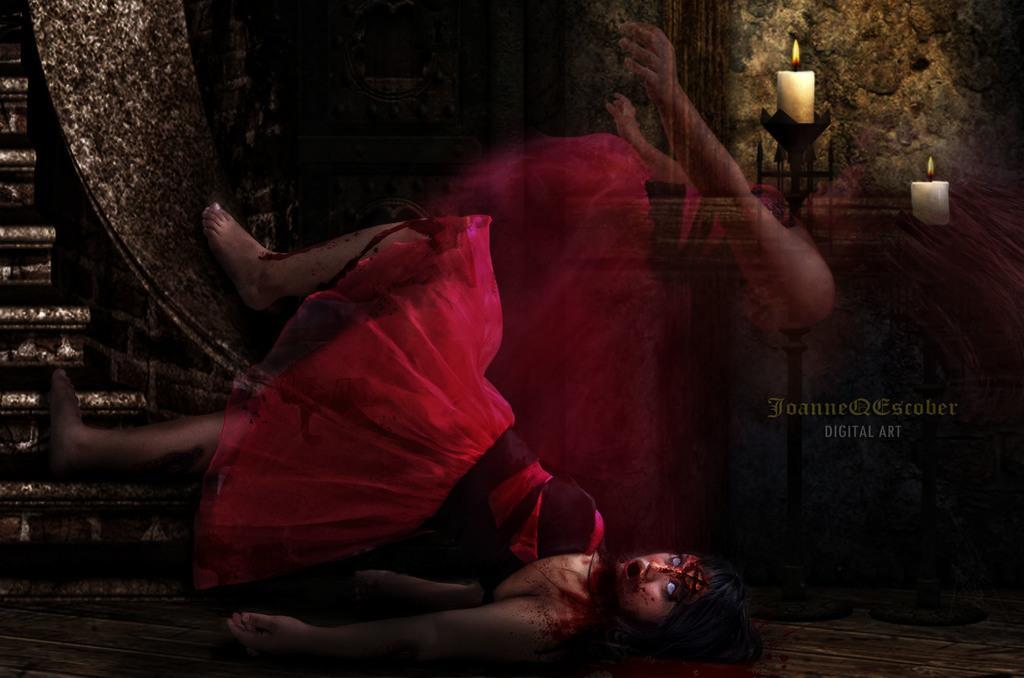Can you describe this image briefly? In the picture we can see a woman with the red dress and a different costume seems like a spirit and on her we can see a transparent body of her and in the background, we can see a wall and near it we can see a stand with candles and light to it. 